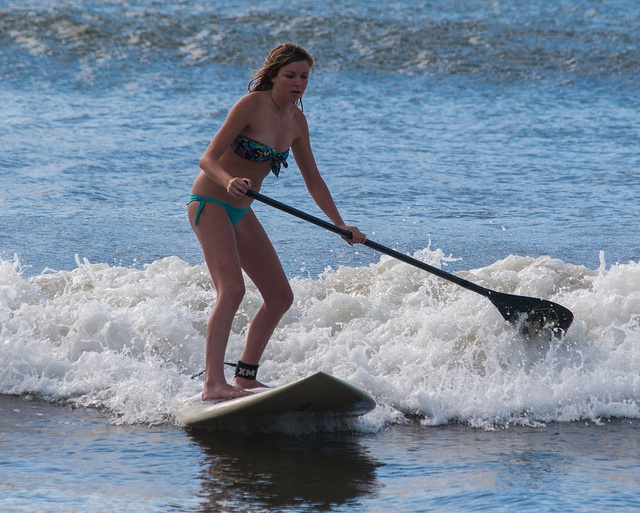Describe the objects in this image and their specific colors. I can see people in gray, maroon, brown, black, and darkgray tones and surfboard in gray, black, darkgray, and lightgray tones in this image. 